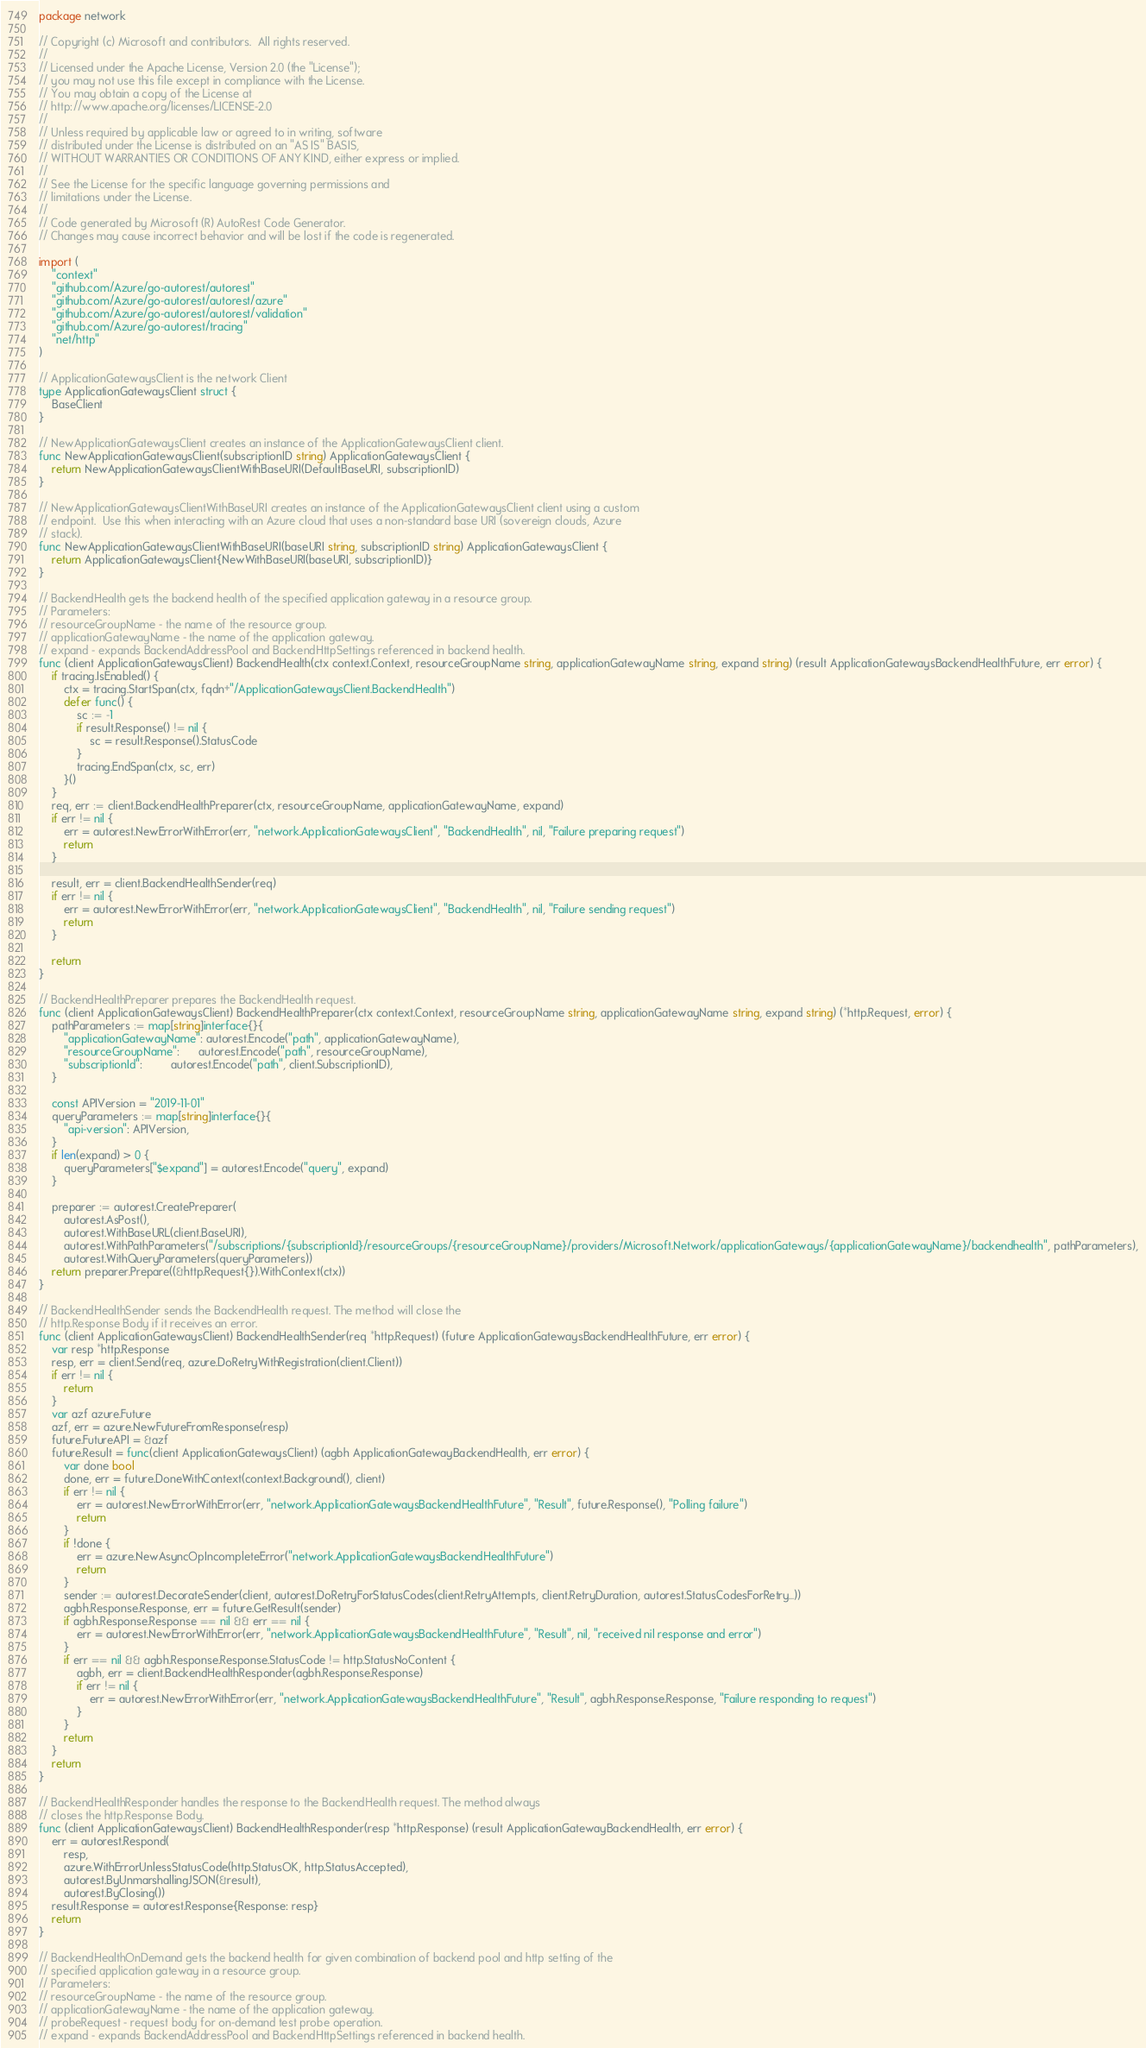Convert code to text. <code><loc_0><loc_0><loc_500><loc_500><_Go_>package network

// Copyright (c) Microsoft and contributors.  All rights reserved.
//
// Licensed under the Apache License, Version 2.0 (the "License");
// you may not use this file except in compliance with the License.
// You may obtain a copy of the License at
// http://www.apache.org/licenses/LICENSE-2.0
//
// Unless required by applicable law or agreed to in writing, software
// distributed under the License is distributed on an "AS IS" BASIS,
// WITHOUT WARRANTIES OR CONDITIONS OF ANY KIND, either express or implied.
//
// See the License for the specific language governing permissions and
// limitations under the License.
//
// Code generated by Microsoft (R) AutoRest Code Generator.
// Changes may cause incorrect behavior and will be lost if the code is regenerated.

import (
	"context"
	"github.com/Azure/go-autorest/autorest"
	"github.com/Azure/go-autorest/autorest/azure"
	"github.com/Azure/go-autorest/autorest/validation"
	"github.com/Azure/go-autorest/tracing"
	"net/http"
)

// ApplicationGatewaysClient is the network Client
type ApplicationGatewaysClient struct {
	BaseClient
}

// NewApplicationGatewaysClient creates an instance of the ApplicationGatewaysClient client.
func NewApplicationGatewaysClient(subscriptionID string) ApplicationGatewaysClient {
	return NewApplicationGatewaysClientWithBaseURI(DefaultBaseURI, subscriptionID)
}

// NewApplicationGatewaysClientWithBaseURI creates an instance of the ApplicationGatewaysClient client using a custom
// endpoint.  Use this when interacting with an Azure cloud that uses a non-standard base URI (sovereign clouds, Azure
// stack).
func NewApplicationGatewaysClientWithBaseURI(baseURI string, subscriptionID string) ApplicationGatewaysClient {
	return ApplicationGatewaysClient{NewWithBaseURI(baseURI, subscriptionID)}
}

// BackendHealth gets the backend health of the specified application gateway in a resource group.
// Parameters:
// resourceGroupName - the name of the resource group.
// applicationGatewayName - the name of the application gateway.
// expand - expands BackendAddressPool and BackendHttpSettings referenced in backend health.
func (client ApplicationGatewaysClient) BackendHealth(ctx context.Context, resourceGroupName string, applicationGatewayName string, expand string) (result ApplicationGatewaysBackendHealthFuture, err error) {
	if tracing.IsEnabled() {
		ctx = tracing.StartSpan(ctx, fqdn+"/ApplicationGatewaysClient.BackendHealth")
		defer func() {
			sc := -1
			if result.Response() != nil {
				sc = result.Response().StatusCode
			}
			tracing.EndSpan(ctx, sc, err)
		}()
	}
	req, err := client.BackendHealthPreparer(ctx, resourceGroupName, applicationGatewayName, expand)
	if err != nil {
		err = autorest.NewErrorWithError(err, "network.ApplicationGatewaysClient", "BackendHealth", nil, "Failure preparing request")
		return
	}

	result, err = client.BackendHealthSender(req)
	if err != nil {
		err = autorest.NewErrorWithError(err, "network.ApplicationGatewaysClient", "BackendHealth", nil, "Failure sending request")
		return
	}

	return
}

// BackendHealthPreparer prepares the BackendHealth request.
func (client ApplicationGatewaysClient) BackendHealthPreparer(ctx context.Context, resourceGroupName string, applicationGatewayName string, expand string) (*http.Request, error) {
	pathParameters := map[string]interface{}{
		"applicationGatewayName": autorest.Encode("path", applicationGatewayName),
		"resourceGroupName":      autorest.Encode("path", resourceGroupName),
		"subscriptionId":         autorest.Encode("path", client.SubscriptionID),
	}

	const APIVersion = "2019-11-01"
	queryParameters := map[string]interface{}{
		"api-version": APIVersion,
	}
	if len(expand) > 0 {
		queryParameters["$expand"] = autorest.Encode("query", expand)
	}

	preparer := autorest.CreatePreparer(
		autorest.AsPost(),
		autorest.WithBaseURL(client.BaseURI),
		autorest.WithPathParameters("/subscriptions/{subscriptionId}/resourceGroups/{resourceGroupName}/providers/Microsoft.Network/applicationGateways/{applicationGatewayName}/backendhealth", pathParameters),
		autorest.WithQueryParameters(queryParameters))
	return preparer.Prepare((&http.Request{}).WithContext(ctx))
}

// BackendHealthSender sends the BackendHealth request. The method will close the
// http.Response Body if it receives an error.
func (client ApplicationGatewaysClient) BackendHealthSender(req *http.Request) (future ApplicationGatewaysBackendHealthFuture, err error) {
	var resp *http.Response
	resp, err = client.Send(req, azure.DoRetryWithRegistration(client.Client))
	if err != nil {
		return
	}
	var azf azure.Future
	azf, err = azure.NewFutureFromResponse(resp)
	future.FutureAPI = &azf
	future.Result = func(client ApplicationGatewaysClient) (agbh ApplicationGatewayBackendHealth, err error) {
		var done bool
		done, err = future.DoneWithContext(context.Background(), client)
		if err != nil {
			err = autorest.NewErrorWithError(err, "network.ApplicationGatewaysBackendHealthFuture", "Result", future.Response(), "Polling failure")
			return
		}
		if !done {
			err = azure.NewAsyncOpIncompleteError("network.ApplicationGatewaysBackendHealthFuture")
			return
		}
		sender := autorest.DecorateSender(client, autorest.DoRetryForStatusCodes(client.RetryAttempts, client.RetryDuration, autorest.StatusCodesForRetry...))
		agbh.Response.Response, err = future.GetResult(sender)
		if agbh.Response.Response == nil && err == nil {
			err = autorest.NewErrorWithError(err, "network.ApplicationGatewaysBackendHealthFuture", "Result", nil, "received nil response and error")
		}
		if err == nil && agbh.Response.Response.StatusCode != http.StatusNoContent {
			agbh, err = client.BackendHealthResponder(agbh.Response.Response)
			if err != nil {
				err = autorest.NewErrorWithError(err, "network.ApplicationGatewaysBackendHealthFuture", "Result", agbh.Response.Response, "Failure responding to request")
			}
		}
		return
	}
	return
}

// BackendHealthResponder handles the response to the BackendHealth request. The method always
// closes the http.Response Body.
func (client ApplicationGatewaysClient) BackendHealthResponder(resp *http.Response) (result ApplicationGatewayBackendHealth, err error) {
	err = autorest.Respond(
		resp,
		azure.WithErrorUnlessStatusCode(http.StatusOK, http.StatusAccepted),
		autorest.ByUnmarshallingJSON(&result),
		autorest.ByClosing())
	result.Response = autorest.Response{Response: resp}
	return
}

// BackendHealthOnDemand gets the backend health for given combination of backend pool and http setting of the
// specified application gateway in a resource group.
// Parameters:
// resourceGroupName - the name of the resource group.
// applicationGatewayName - the name of the application gateway.
// probeRequest - request body for on-demand test probe operation.
// expand - expands BackendAddressPool and BackendHttpSettings referenced in backend health.</code> 